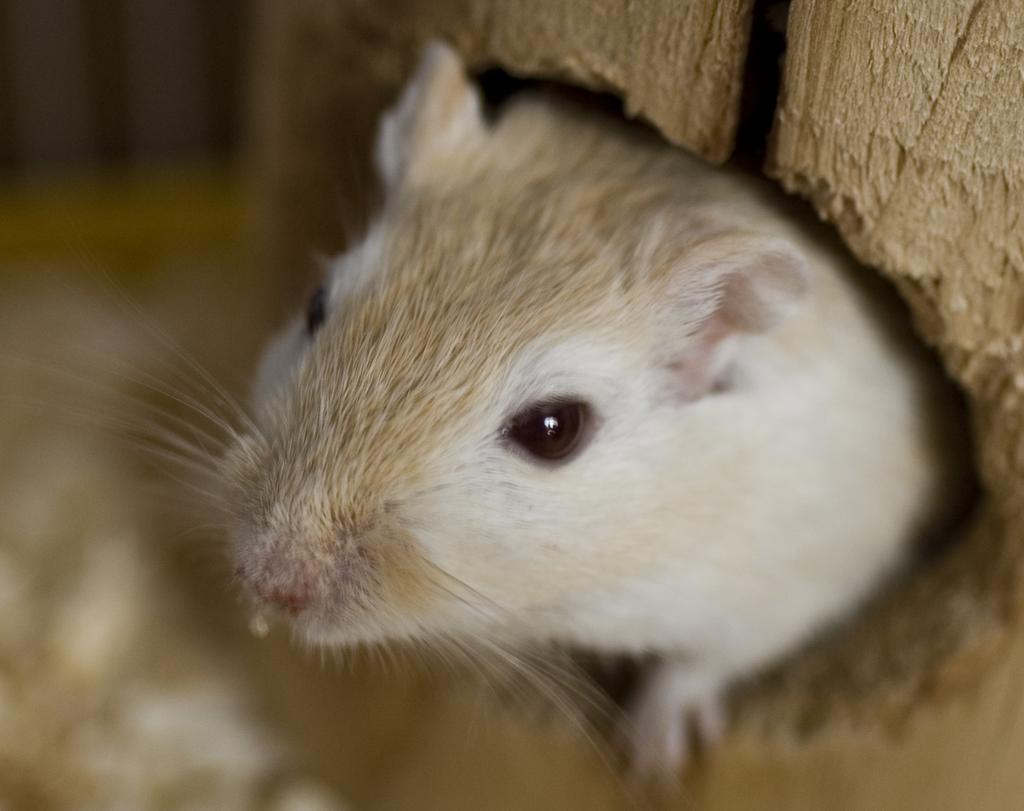What animal is present in the image? There is a rat in the image. Can you describe the rat's coloring? The rat has white and brown coloring. What can be said about the background of the image? The background of the image is blurred. What type of yak can be seen in the image? There is no yak present in the image; it features a rat with white and brown coloring. How many needles are visible in the image? There are no needles present in the image. 